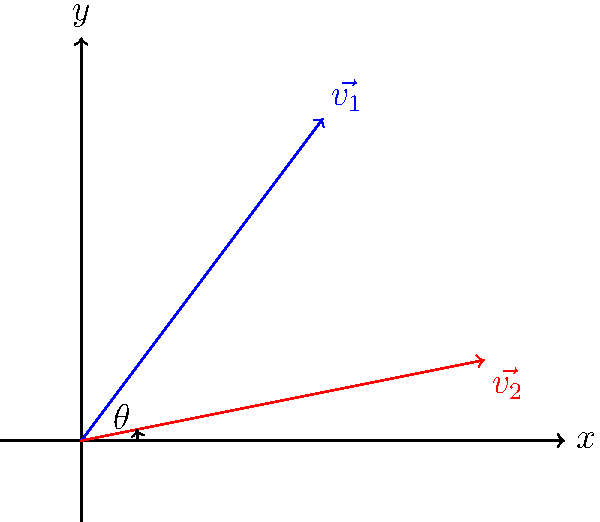In an Australian rules football match, two players kick the ball simultaneously from the same point. The trajectory of the first kick can be represented by the vector $\vec{v_1} = 3\hat{i} + 4\hat{j}$, while the second kick's trajectory is represented by $\vec{v_2} = 5\hat{i} + \hat{j}$. What is the angle $\theta$ (in degrees, rounded to the nearest whole number) between these two kick trajectories? To find the angle between two vectors, we can use the dot product formula:

$$\cos \theta = \frac{\vec{v_1} \cdot \vec{v_2}}{|\vec{v_1}||\vec{v_2}|}$$

Step 1: Calculate the dot product $\vec{v_1} \cdot \vec{v_2}$
$$\vec{v_1} \cdot \vec{v_2} = (3)(5) + (4)(1) = 15 + 4 = 19$$

Step 2: Calculate the magnitudes of the vectors
$$|\vec{v_1}| = \sqrt{3^2 + 4^2} = \sqrt{9 + 16} = \sqrt{25} = 5$$
$$|\vec{v_2}| = \sqrt{5^2 + 1^2} = \sqrt{25 + 1} = \sqrt{26}$$

Step 3: Apply the dot product formula
$$\cos \theta = \frac{19}{5\sqrt{26}}$$

Step 4: Take the inverse cosine (arccos) of both sides
$$\theta = \arccos(\frac{19}{5\sqrt{26}})$$

Step 5: Calculate the result and convert to degrees
$$\theta \approx 0.4859 \text{ radians}$$
$$\theta \approx 0.4859 \times \frac{180}{\pi} \approx 27.84^\circ$$

Step 6: Round to the nearest whole number
$$\theta \approx 28^\circ$$
Answer: 28° 